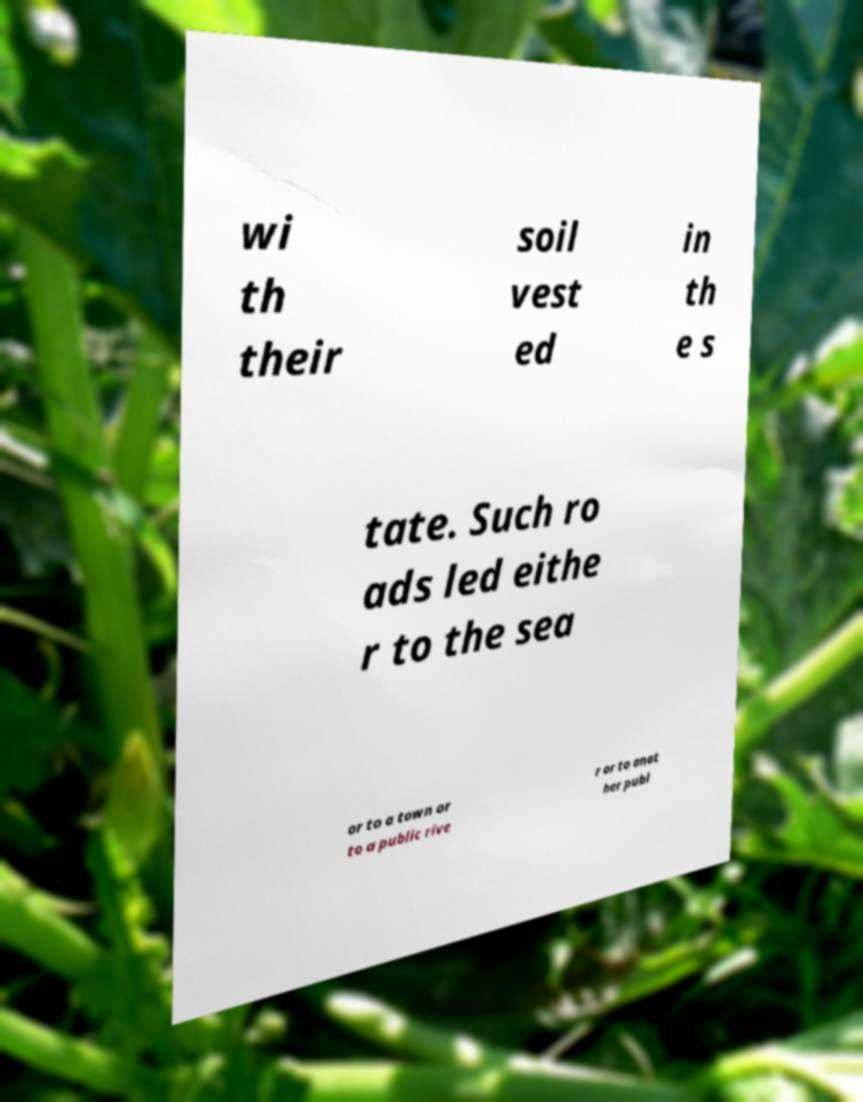I need the written content from this picture converted into text. Can you do that? wi th their soil vest ed in th e s tate. Such ro ads led eithe r to the sea or to a town or to a public rive r or to anot her publ 